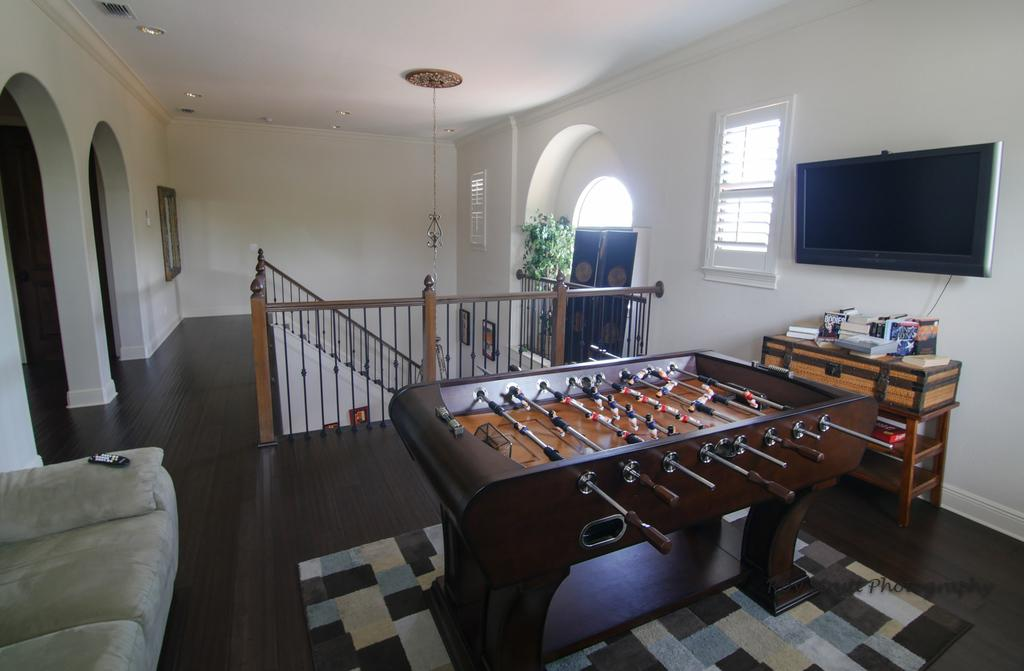What type of game can be seen in the image? There is a table football in the image. What electronic device is present in the image? There is a T.V. in the image. What architectural feature is visible in the image? There is a staircase in the image. What type of seating is on the left side of the image? There is a sofa on the left side of the image. Where are the tomatoes placed in the image? There are no tomatoes present in the image. What type of cloth is draped over the sofa in the image? There is no cloth draped over the sofa in the image. What type of yoke is used to control the table football in the image? There is no yoke present in the image; table football is controlled by handles. 